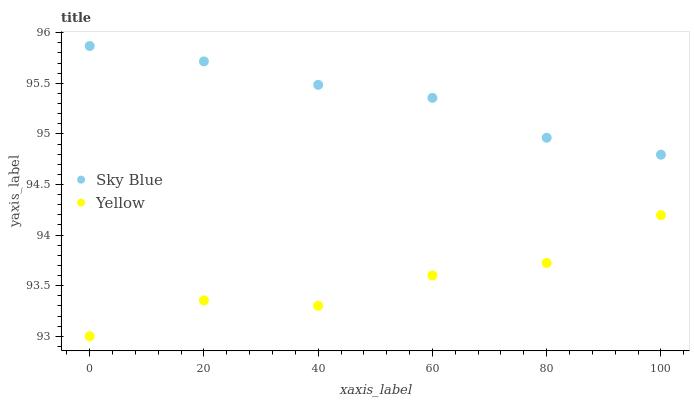Does Yellow have the minimum area under the curve?
Answer yes or no. Yes. Does Sky Blue have the maximum area under the curve?
Answer yes or no. Yes. Does Yellow have the maximum area under the curve?
Answer yes or no. No. Is Sky Blue the smoothest?
Answer yes or no. Yes. Is Yellow the roughest?
Answer yes or no. Yes. Is Yellow the smoothest?
Answer yes or no. No. Does Yellow have the lowest value?
Answer yes or no. Yes. Does Sky Blue have the highest value?
Answer yes or no. Yes. Does Yellow have the highest value?
Answer yes or no. No. Is Yellow less than Sky Blue?
Answer yes or no. Yes. Is Sky Blue greater than Yellow?
Answer yes or no. Yes. Does Yellow intersect Sky Blue?
Answer yes or no. No. 